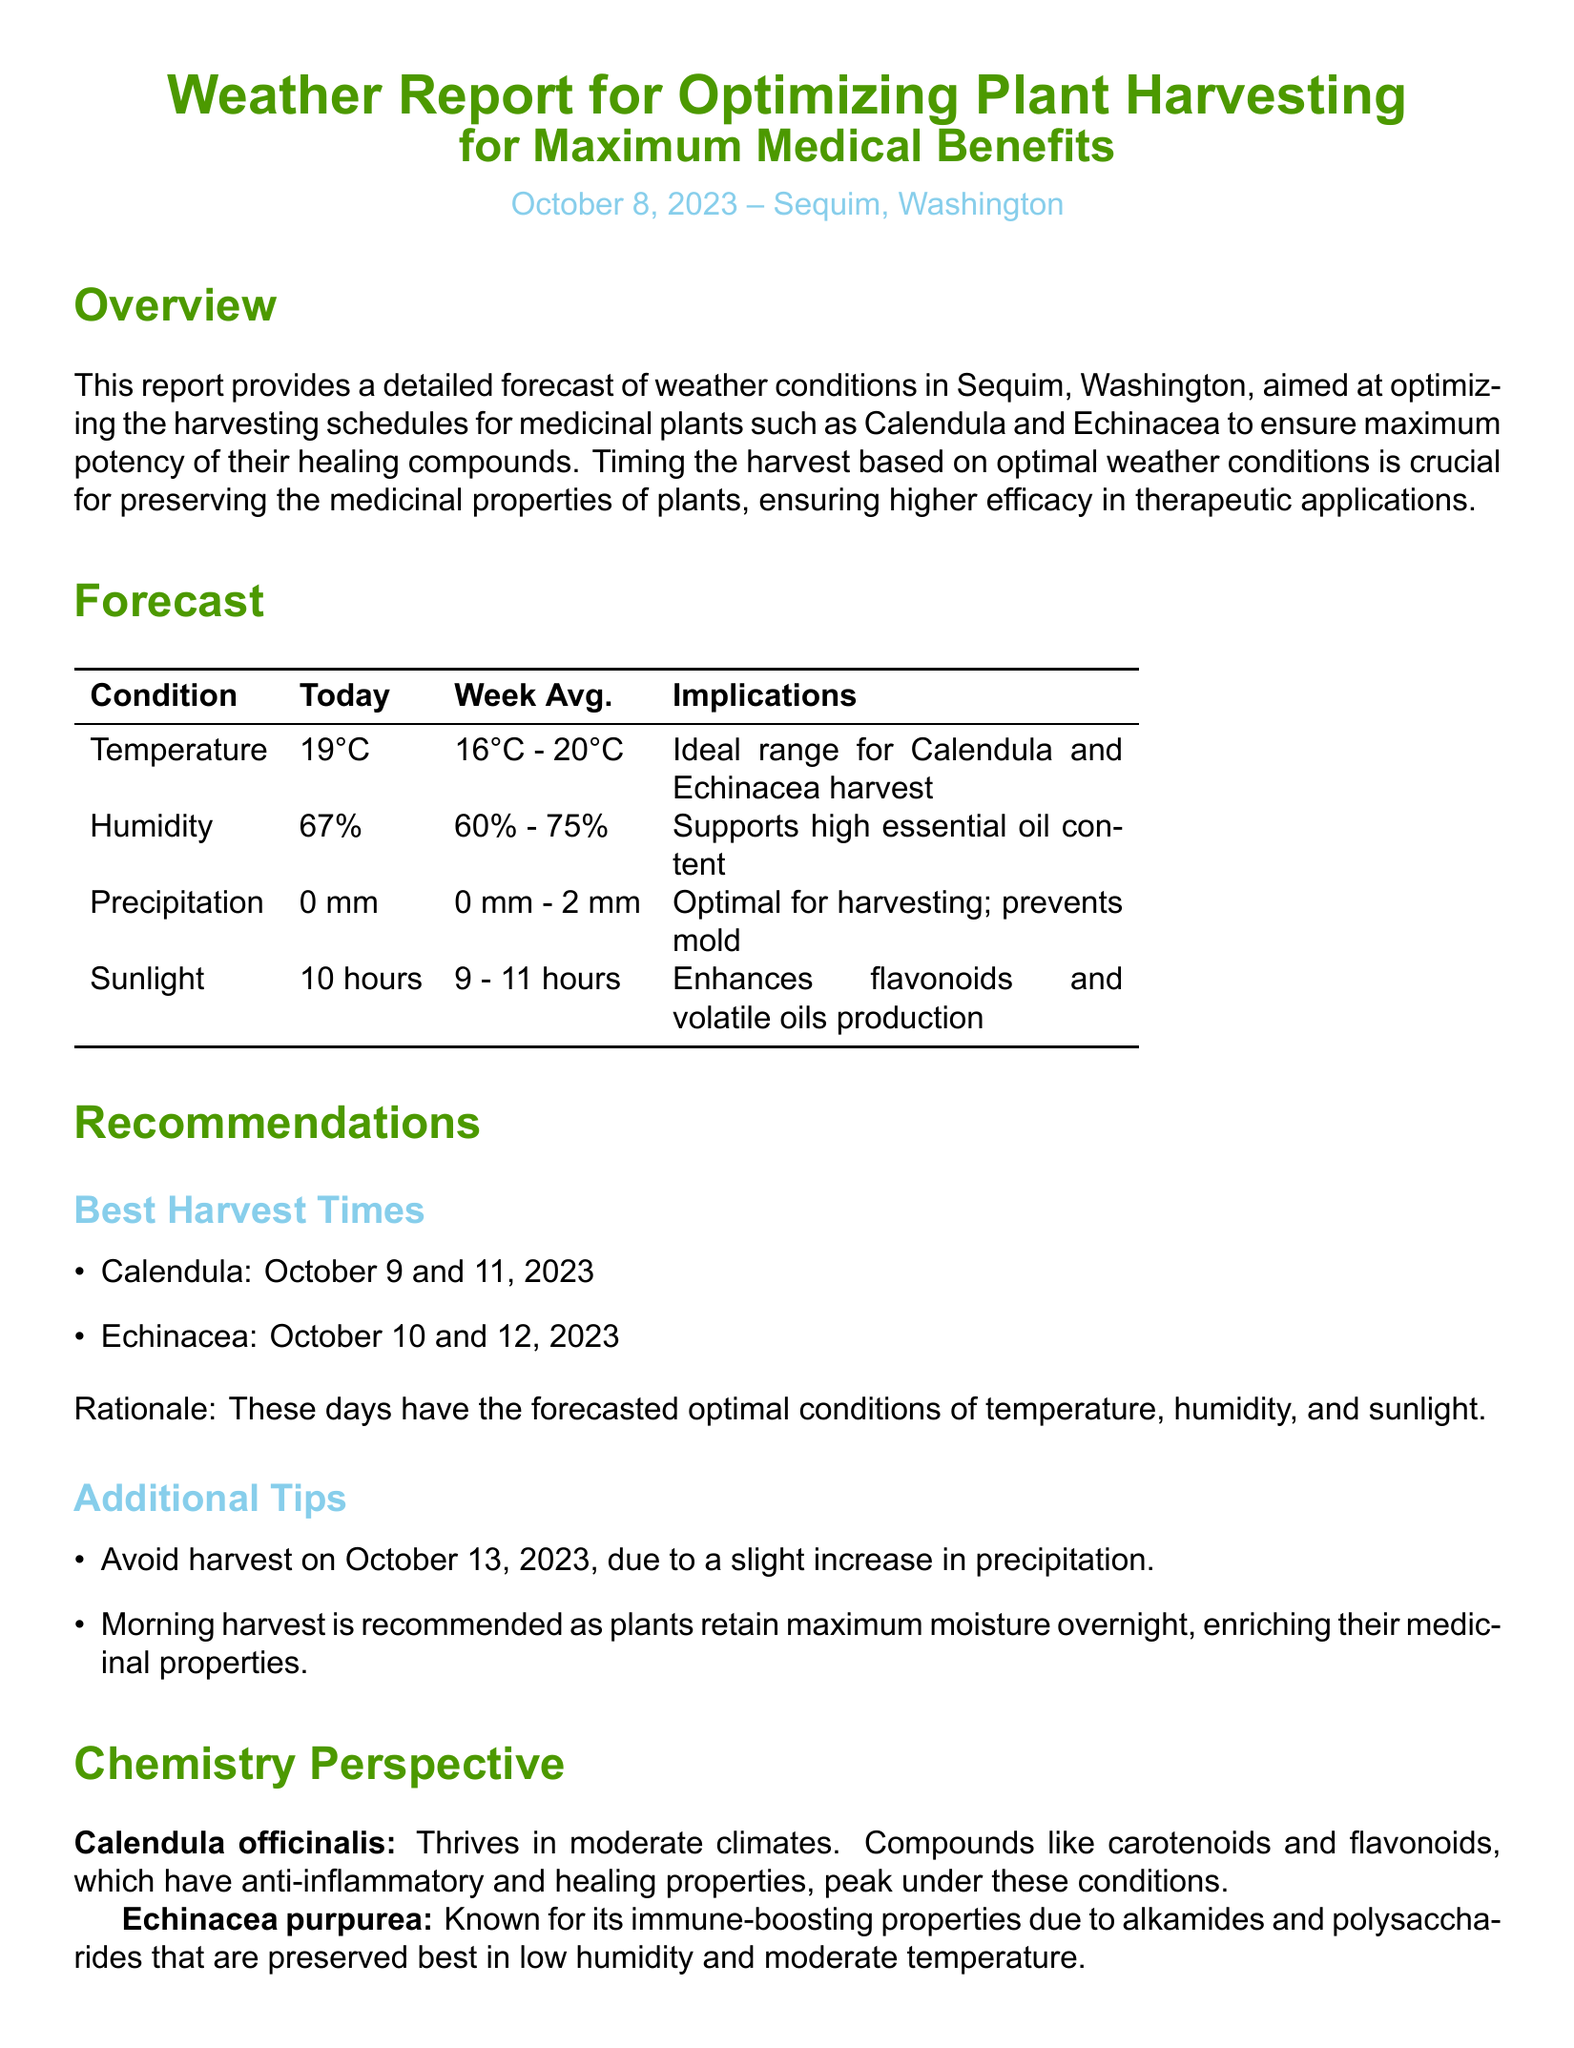What is the temperature forecast for today? The temperature forecast for today is specifically provided in the document.
Answer: 19°C What is the week average humidity? The week average humidity is calculated based on the data presented in the document.
Answer: 60% - 75% What are the best harvest dates for Echinacea? The best harvest dates are specifically listed in the recommendations section of the document.
Answer: October 10 and 12, 2023 What is the implication of sunlight being 10 hours? The significance of sunlight duration is addressed in the forecast, indicating its benefits for plant compounds.
Answer: Enhances flavonoids and volatile oils production What compounds in Calendula are noted for their healing properties? The document provides specific information about the compounds found in Calendula related to its medicinal benefits.
Answer: Carotenoids and flavonoids Why is the morning harvest recommended? The document contains a rationale for why morning harvesting is advantageous for plant properties.
Answer: Plants retain maximum moisture overnight What should be avoided on October 13, 2023? The document specifically mentions a precaution regarding the harvesting schedule on that date.
Answer: Slight increase in precipitation Which plant is known for immune-boosting properties? The document identifies specific plants and their known benefits, indicating their medicinal uses.
Answer: Echinacea purpurea 